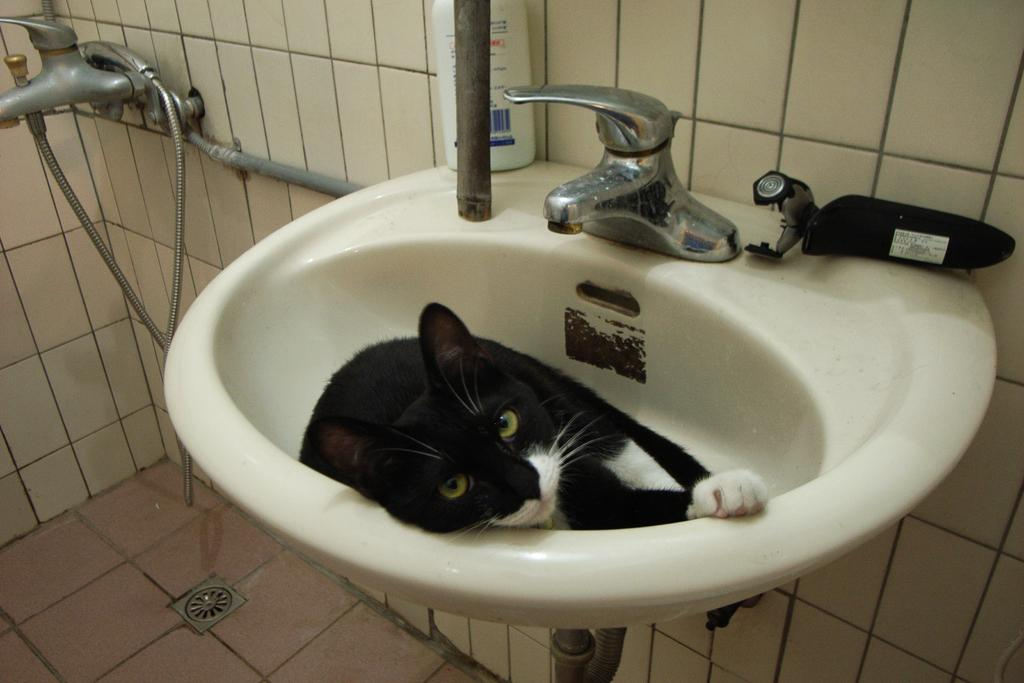What animal is in the wash basin in the image? There is a cat in the wash basin in the image. What type of objects can be seen in the image besides the cat? There are tapes and a bottle in the image, as well as other unspecified objects. What can be seen in the background of the image? There are walls in the image, and the floor has marbles. What type of bait is the cat using to attract fish in the image? There is no indication in the image that the cat is using bait or trying to attract fish. 